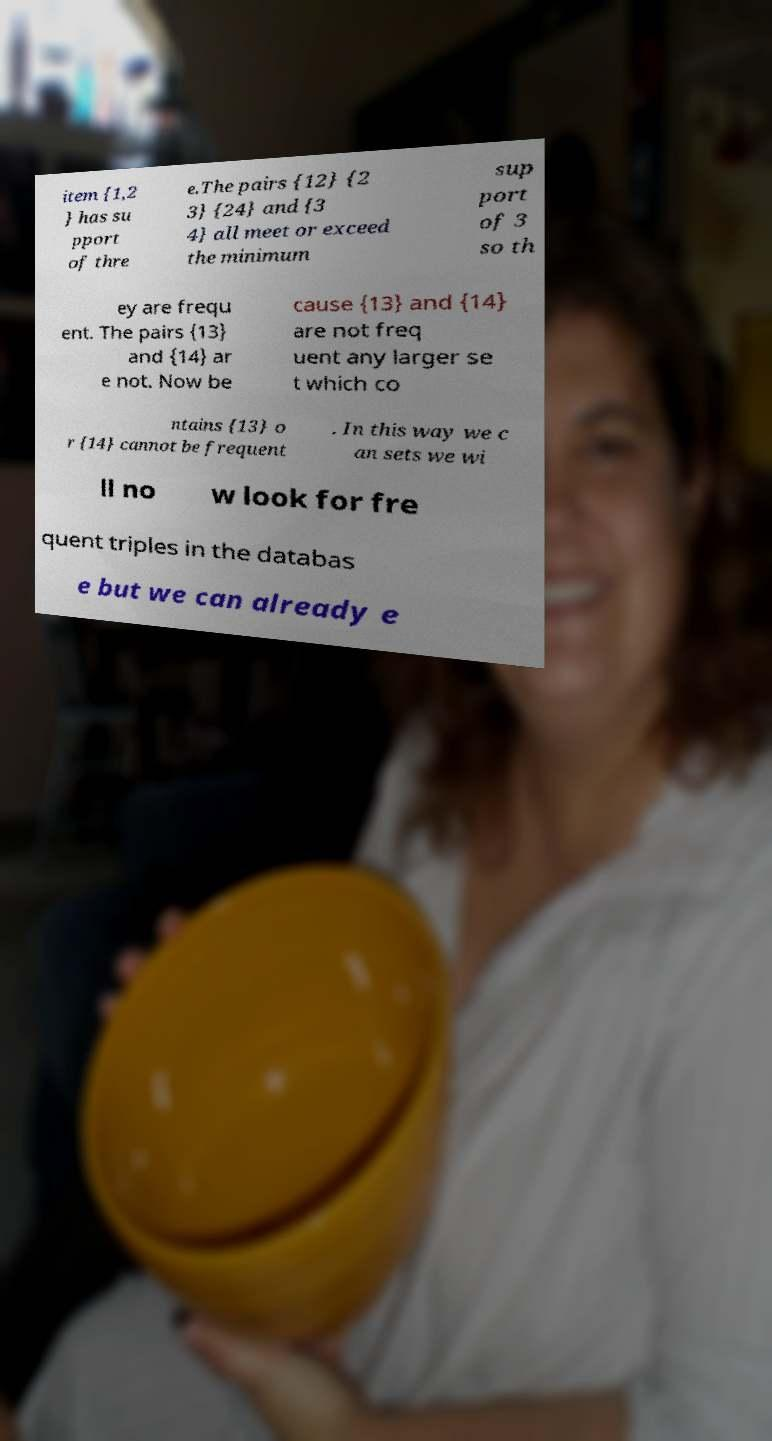I need the written content from this picture converted into text. Can you do that? item {1,2 } has su pport of thre e.The pairs {12} {2 3} {24} and {3 4} all meet or exceed the minimum sup port of 3 so th ey are frequ ent. The pairs {13} and {14} ar e not. Now be cause {13} and {14} are not freq uent any larger se t which co ntains {13} o r {14} cannot be frequent . In this way we c an sets we wi ll no w look for fre quent triples in the databas e but we can already e 